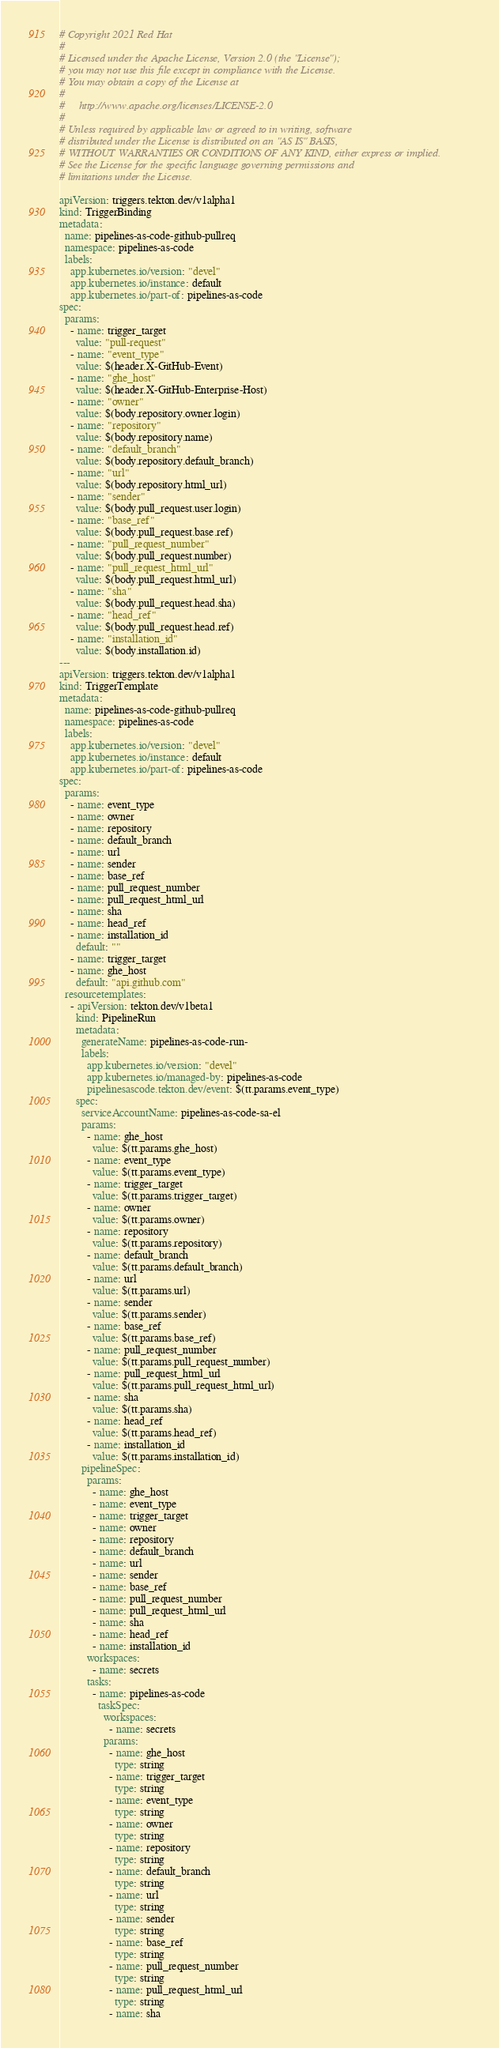Convert code to text. <code><loc_0><loc_0><loc_500><loc_500><_YAML_># Copyright 2021 Red Hat
#
# Licensed under the Apache License, Version 2.0 (the "License");
# you may not use this file except in compliance with the License.
# You may obtain a copy of the License at
#
#     http://www.apache.org/licenses/LICENSE-2.0
#
# Unless required by applicable law or agreed to in writing, software
# distributed under the License is distributed on an "AS IS" BASIS,
# WITHOUT WARRANTIES OR CONDITIONS OF ANY KIND, either express or implied.
# See the License for the specific language governing permissions and
# limitations under the License.

apiVersion: triggers.tekton.dev/v1alpha1
kind: TriggerBinding
metadata:
  name: pipelines-as-code-github-pullreq
  namespace: pipelines-as-code
  labels:
    app.kubernetes.io/version: "devel"
    app.kubernetes.io/instance: default
    app.kubernetes.io/part-of: pipelines-as-code
spec:
  params:
    - name: trigger_target
      value: "pull-request"
    - name: "event_type"
      value: $(header.X-GitHub-Event)
    - name: "ghe_host"
      value: $(header.X-GitHub-Enterprise-Host)
    - name: "owner"
      value: $(body.repository.owner.login)
    - name: "repository"
      value: $(body.repository.name)
    - name: "default_branch"
      value: $(body.repository.default_branch)
    - name: "url"
      value: $(body.repository.html_url)
    - name: "sender"
      value: $(body.pull_request.user.login)
    - name: "base_ref"
      value: $(body.pull_request.base.ref)
    - name: "pull_request_number"
      value: $(body.pull_request.number)
    - name: "pull_request_html_url"
      value: $(body.pull_request.html_url)
    - name: "sha"
      value: $(body.pull_request.head.sha)
    - name: "head_ref"
      value: $(body.pull_request.head.ref)
    - name: "installation_id"
      value: $(body.installation.id)
---
apiVersion: triggers.tekton.dev/v1alpha1
kind: TriggerTemplate
metadata:
  name: pipelines-as-code-github-pullreq
  namespace: pipelines-as-code
  labels:
    app.kubernetes.io/version: "devel"
    app.kubernetes.io/instance: default
    app.kubernetes.io/part-of: pipelines-as-code
spec:
  params:
    - name: event_type
    - name: owner
    - name: repository
    - name: default_branch
    - name: url
    - name: sender
    - name: base_ref
    - name: pull_request_number
    - name: pull_request_html_url
    - name: sha
    - name: head_ref
    - name: installation_id
      default: ""
    - name: trigger_target
    - name: ghe_host
      default: "api.github.com"
  resourcetemplates:
    - apiVersion: tekton.dev/v1beta1
      kind: PipelineRun
      metadata:
        generateName: pipelines-as-code-run-
        labels:
          app.kubernetes.io/version: "devel"
          app.kubernetes.io/managed-by: pipelines-as-code
          pipelinesascode.tekton.dev/event: $(tt.params.event_type)
      spec:
        serviceAccountName: pipelines-as-code-sa-el
        params:
          - name: ghe_host
            value: $(tt.params.ghe_host)
          - name: event_type
            value: $(tt.params.event_type)
          - name: trigger_target
            value: $(tt.params.trigger_target)
          - name: owner
            value: $(tt.params.owner)
          - name: repository
            value: $(tt.params.repository)
          - name: default_branch
            value: $(tt.params.default_branch)
          - name: url
            value: $(tt.params.url)
          - name: sender
            value: $(tt.params.sender)
          - name: base_ref
            value: $(tt.params.base_ref)
          - name: pull_request_number
            value: $(tt.params.pull_request_number)
          - name: pull_request_html_url
            value: $(tt.params.pull_request_html_url)
          - name: sha
            value: $(tt.params.sha)
          - name: head_ref
            value: $(tt.params.head_ref)
          - name: installation_id
            value: $(tt.params.installation_id)
        pipelineSpec:
          params:
            - name: ghe_host
            - name: event_type
            - name: trigger_target
            - name: owner
            - name: repository
            - name: default_branch
            - name: url
            - name: sender
            - name: base_ref
            - name: pull_request_number
            - name: pull_request_html_url
            - name: sha
            - name: head_ref
            - name: installation_id
          workspaces:
            - name: secrets
          tasks:
            - name: pipelines-as-code
              taskSpec:
                workspaces:
                  - name: secrets
                params:
                  - name: ghe_host
                    type: string
                  - name: trigger_target
                    type: string
                  - name: event_type
                    type: string
                  - name: owner
                    type: string
                  - name: repository
                    type: string
                  - name: default_branch
                    type: string
                  - name: url
                    type: string
                  - name: sender
                    type: string
                  - name: base_ref
                    type: string
                  - name: pull_request_number
                    type: string
                  - name: pull_request_html_url
                    type: string
                  - name: sha</code> 